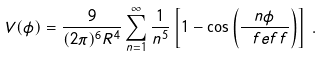<formula> <loc_0><loc_0><loc_500><loc_500>V ( \phi ) = \frac { 9 } { ( 2 \pi ) ^ { 6 } R ^ { 4 } } \sum _ { n = 1 } ^ { \infty } \frac { 1 } { n ^ { 5 } } \left [ 1 - \cos \left ( \frac { n \phi } { \ f e f f } \right ) \right ] \, .</formula> 